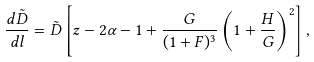<formula> <loc_0><loc_0><loc_500><loc_500>\frac { d \tilde { D } } { d l } = \tilde { D } \left [ z - 2 \alpha - 1 + \frac { G } { ( 1 + F ) ^ { 3 } } \left ( 1 + \frac { H } { G } \right ) ^ { 2 } \right ] ,</formula> 